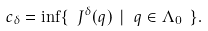Convert formula to latex. <formula><loc_0><loc_0><loc_500><loc_500>c _ { \delta } = \inf \{ \ J ^ { \delta } ( q ) \ | \ q \in \Lambda _ { 0 } \ \} .</formula> 